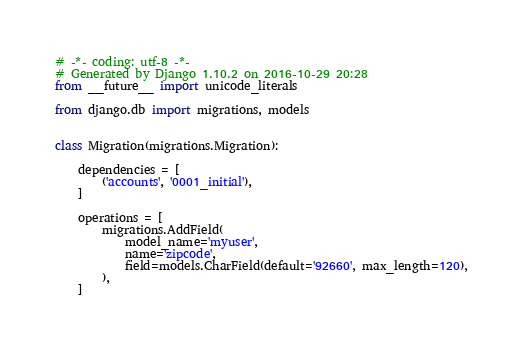<code> <loc_0><loc_0><loc_500><loc_500><_Python_># -*- coding: utf-8 -*-
# Generated by Django 1.10.2 on 2016-10-29 20:28
from __future__ import unicode_literals

from django.db import migrations, models


class Migration(migrations.Migration):

    dependencies = [
        ('accounts', '0001_initial'),
    ]

    operations = [
        migrations.AddField(
            model_name='myuser',
            name='zipcode',
            field=models.CharField(default='92660', max_length=120),
        ),
    ]
</code> 